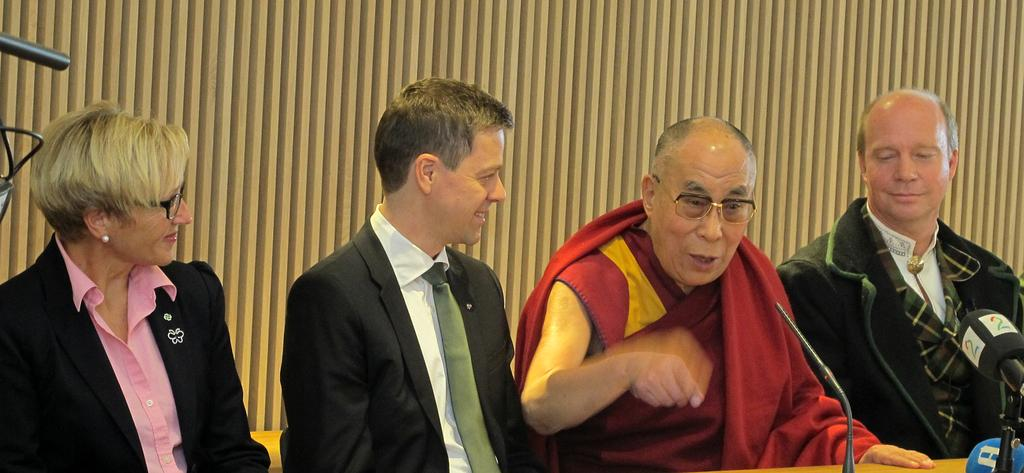What are the people in the image doing? The people in the image are sitting on chairs. What can be seen in the background of the image? There are curtains in the background of the image. What is located in the foreground of the image? There is a table in the foreground of the image. What objects are on the table in the foreground of the image? There are microphones (mics) on the table in the foreground of the image. What type of stocking is visible on the people's legs in the image? There is no mention of stockings or any clothing items on the people's legs in the image. How many pigs are present in the image? There are no pigs present in the image. 